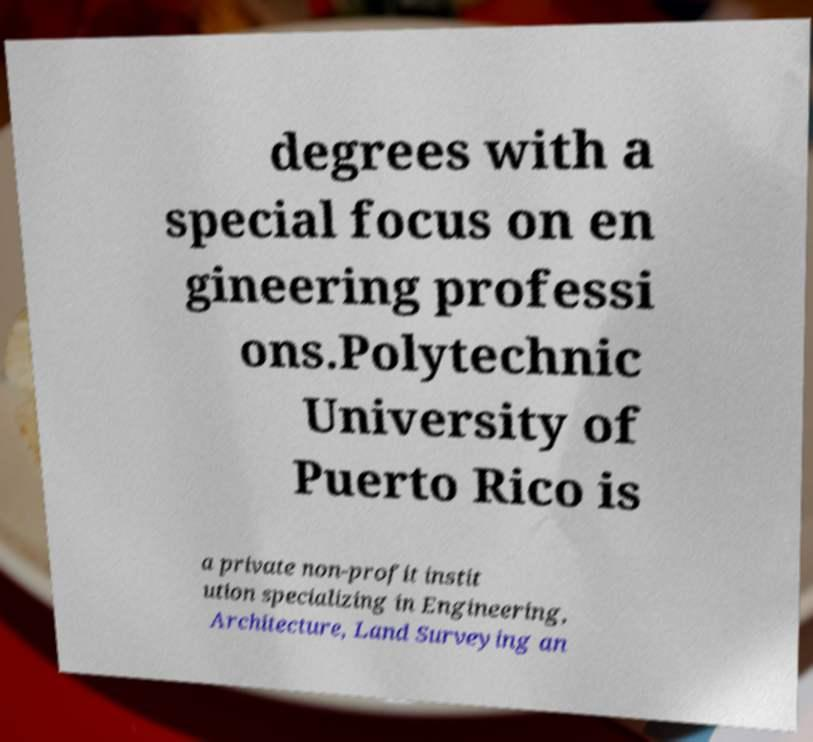Could you assist in decoding the text presented in this image and type it out clearly? degrees with a special focus on en gineering professi ons.Polytechnic University of Puerto Rico is a private non-profit instit ution specializing in Engineering, Architecture, Land Surveying an 